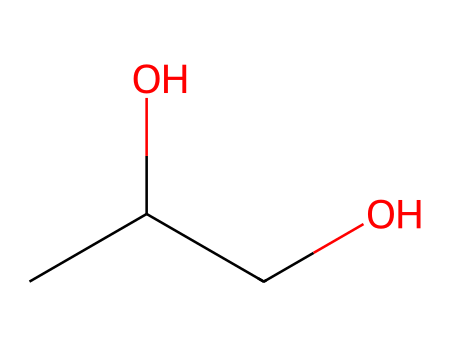What is the name of this chemical? The SMILES representation CC(O)CO corresponds to propylene glycol, which is commonly used in cosmetics and hair products.
Answer: propylene glycol How many carbon atoms are present in this structure? By examining the SMILES representation, "CC" indicates there are two carbon atoms in a row before the rest of the structure. Thus, there are three carbon atoms in total.
Answer: three What functional group is present in propylene glycol? The presence of "O" connected to "C" that also carries a hydrogen atom suggests that there are hydroxyl (-OH) groups in the molecule, indicating that it contains alcohol functional groups.
Answer: alcohol What is the molecular formula of propylene glycol? From the SMILES, we can deduce the molecular formula: there are 3 carbons, 8 hydrogens, and 2 oxygens, leading to the formula C3H8O2.
Answer: C3H8O2 How many hydroxyl groups are found in propylene glycol? Analyzing the structure shows that there are two "O" connected to carbon atoms in the formula, confirming the presence of two hydroxyl groups in propylene glycol.
Answer: two Is propylene glycol hydrophilic or hydrophobic? The presence of hydroxyl groups, which are polar, indicates that propylene glycol can form hydrogen bonds with water, making it hydrophilic.
Answer: hydrophilic What role does propylene glycol play in hair styling products? Its moisture-retaining properties make it crucial in hair products, as it helps to keep hair hydrated and reduce frizz by attracting water.
Answer: moisture-retaining 